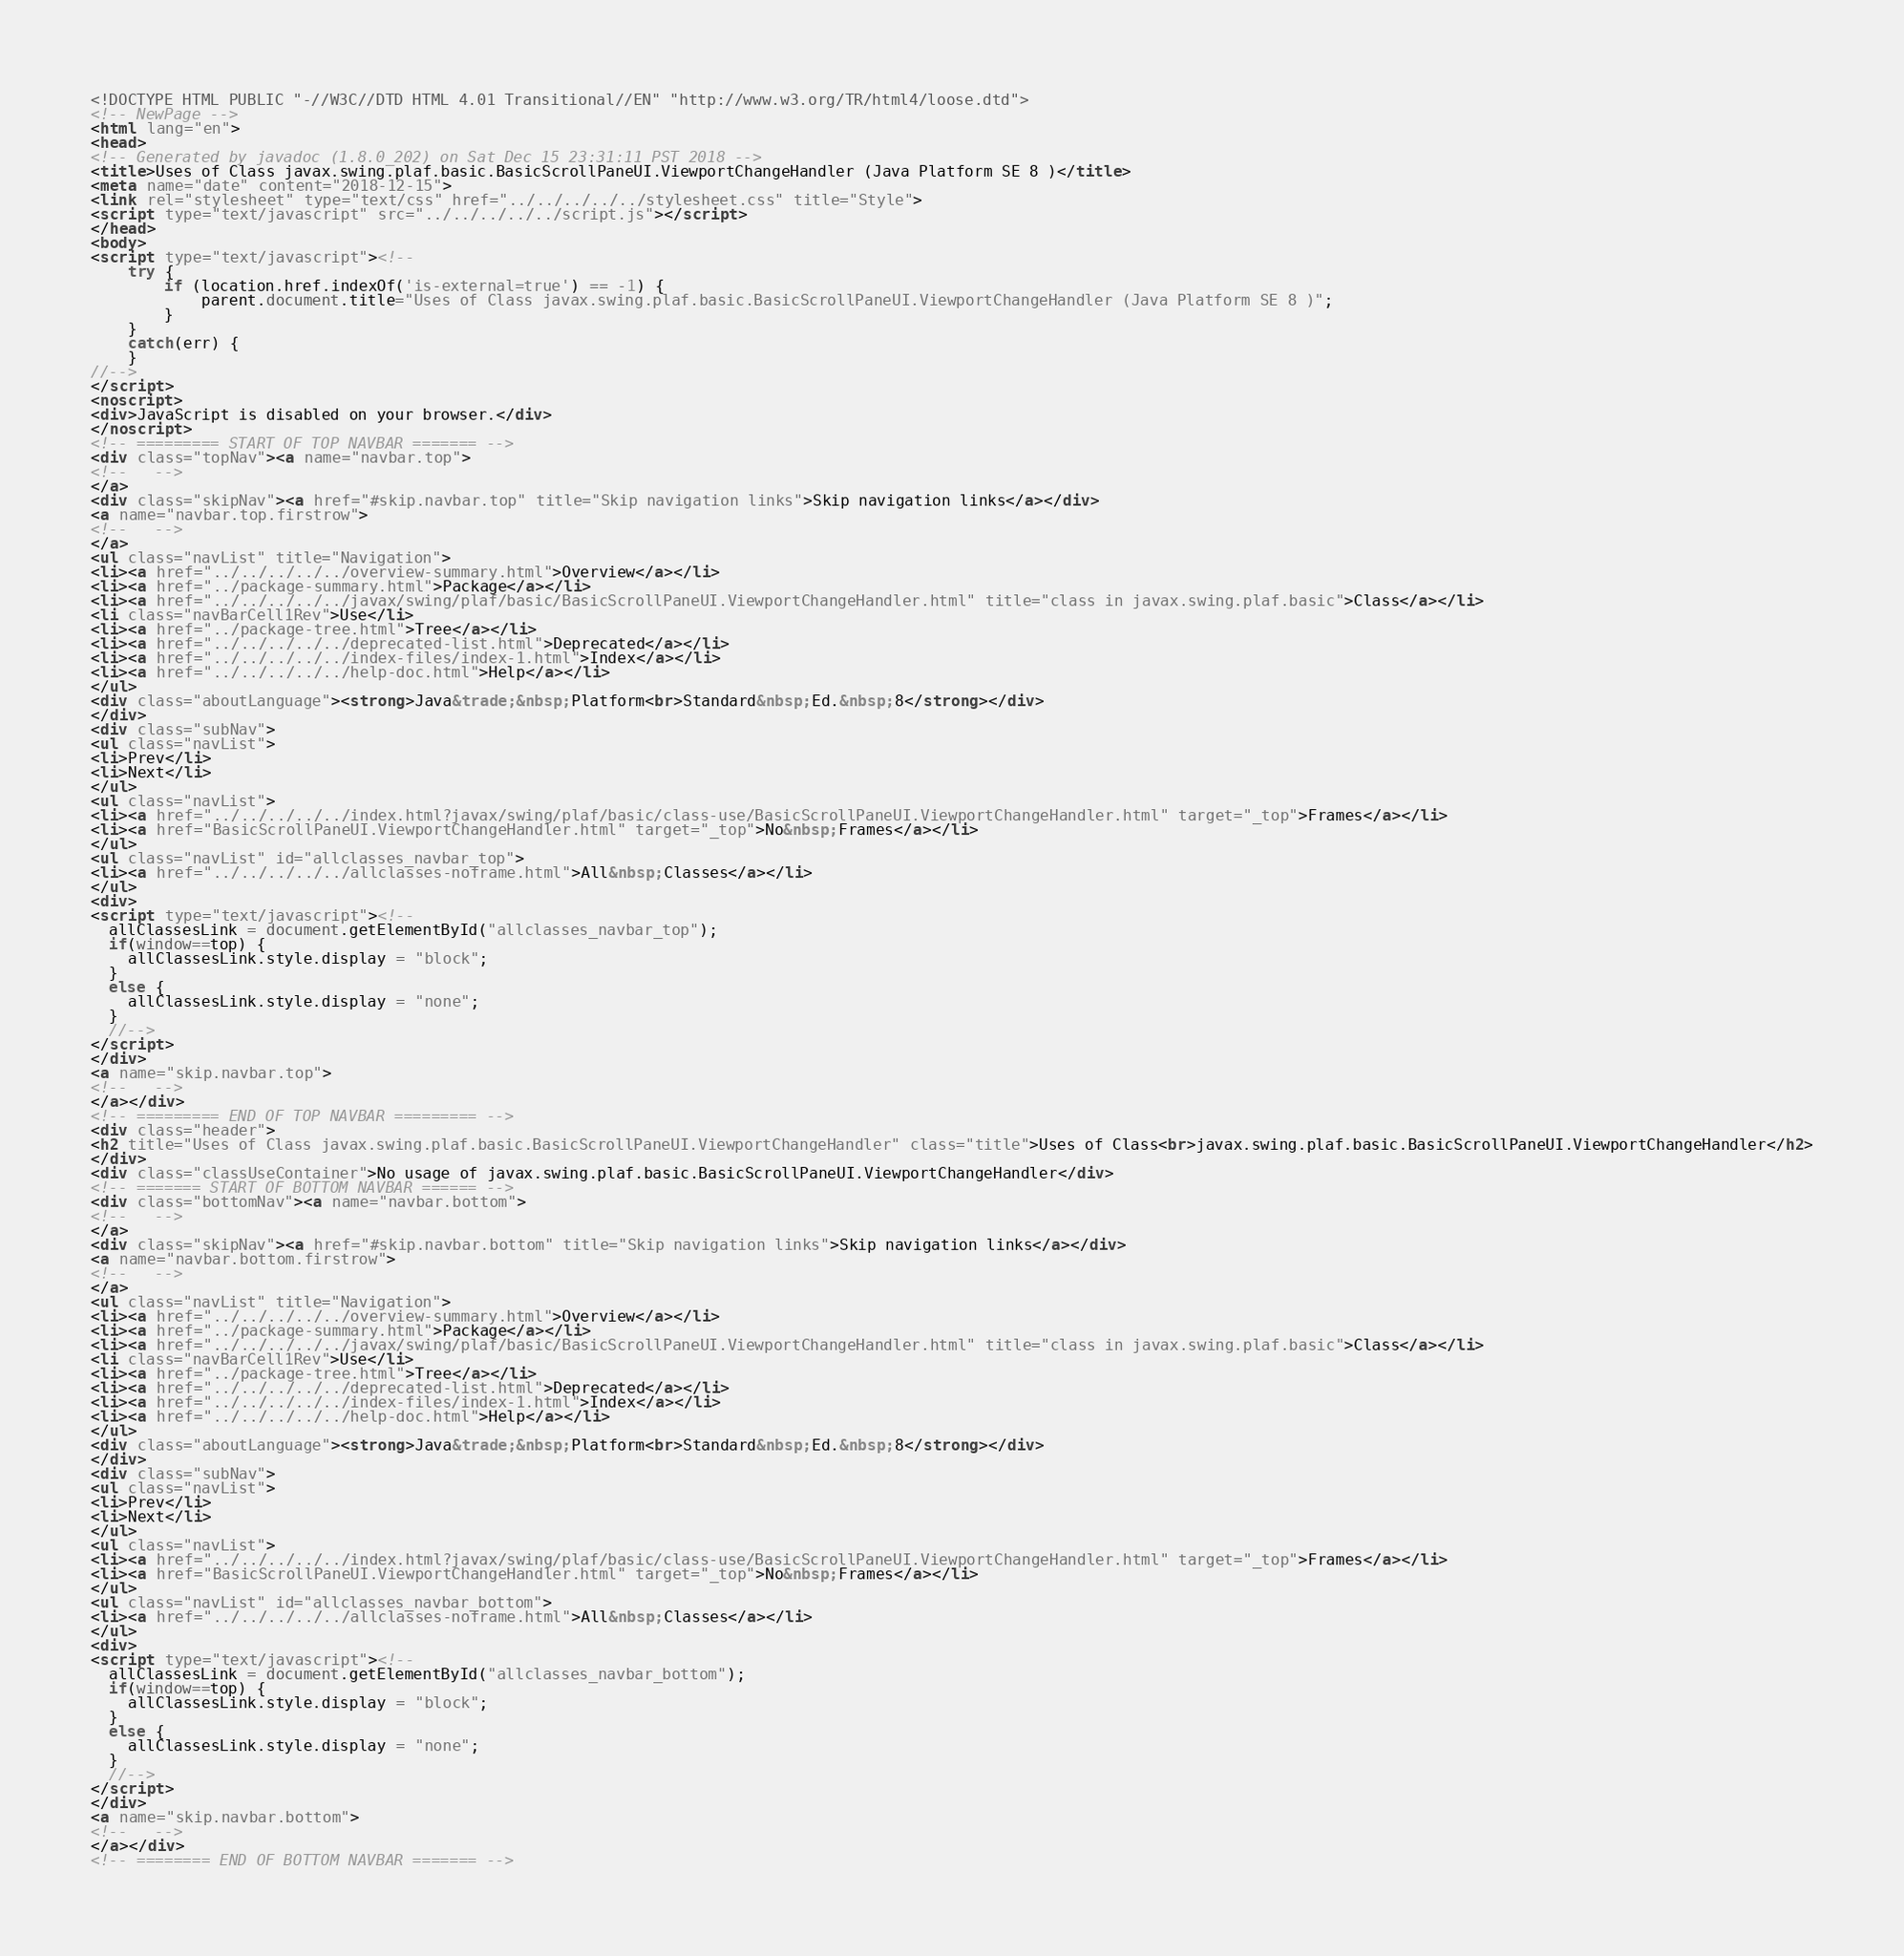Convert code to text. <code><loc_0><loc_0><loc_500><loc_500><_HTML_><!DOCTYPE HTML PUBLIC "-//W3C//DTD HTML 4.01 Transitional//EN" "http://www.w3.org/TR/html4/loose.dtd">
<!-- NewPage -->
<html lang="en">
<head>
<!-- Generated by javadoc (1.8.0_202) on Sat Dec 15 23:31:11 PST 2018 -->
<title>Uses of Class javax.swing.plaf.basic.BasicScrollPaneUI.ViewportChangeHandler (Java Platform SE 8 )</title>
<meta name="date" content="2018-12-15">
<link rel="stylesheet" type="text/css" href="../../../../../stylesheet.css" title="Style">
<script type="text/javascript" src="../../../../../script.js"></script>
</head>
<body>
<script type="text/javascript"><!--
    try {
        if (location.href.indexOf('is-external=true') == -1) {
            parent.document.title="Uses of Class javax.swing.plaf.basic.BasicScrollPaneUI.ViewportChangeHandler (Java Platform SE 8 )";
        }
    }
    catch(err) {
    }
//-->
</script>
<noscript>
<div>JavaScript is disabled on your browser.</div>
</noscript>
<!-- ========= START OF TOP NAVBAR ======= -->
<div class="topNav"><a name="navbar.top">
<!--   -->
</a>
<div class="skipNav"><a href="#skip.navbar.top" title="Skip navigation links">Skip navigation links</a></div>
<a name="navbar.top.firstrow">
<!--   -->
</a>
<ul class="navList" title="Navigation">
<li><a href="../../../../../overview-summary.html">Overview</a></li>
<li><a href="../package-summary.html">Package</a></li>
<li><a href="../../../../../javax/swing/plaf/basic/BasicScrollPaneUI.ViewportChangeHandler.html" title="class in javax.swing.plaf.basic">Class</a></li>
<li class="navBarCell1Rev">Use</li>
<li><a href="../package-tree.html">Tree</a></li>
<li><a href="../../../../../deprecated-list.html">Deprecated</a></li>
<li><a href="../../../../../index-files/index-1.html">Index</a></li>
<li><a href="../../../../../help-doc.html">Help</a></li>
</ul>
<div class="aboutLanguage"><strong>Java&trade;&nbsp;Platform<br>Standard&nbsp;Ed.&nbsp;8</strong></div>
</div>
<div class="subNav">
<ul class="navList">
<li>Prev</li>
<li>Next</li>
</ul>
<ul class="navList">
<li><a href="../../../../../index.html?javax/swing/plaf/basic/class-use/BasicScrollPaneUI.ViewportChangeHandler.html" target="_top">Frames</a></li>
<li><a href="BasicScrollPaneUI.ViewportChangeHandler.html" target="_top">No&nbsp;Frames</a></li>
</ul>
<ul class="navList" id="allclasses_navbar_top">
<li><a href="../../../../../allclasses-noframe.html">All&nbsp;Classes</a></li>
</ul>
<div>
<script type="text/javascript"><!--
  allClassesLink = document.getElementById("allclasses_navbar_top");
  if(window==top) {
    allClassesLink.style.display = "block";
  }
  else {
    allClassesLink.style.display = "none";
  }
  //-->
</script>
</div>
<a name="skip.navbar.top">
<!--   -->
</a></div>
<!-- ========= END OF TOP NAVBAR ========= -->
<div class="header">
<h2 title="Uses of Class javax.swing.plaf.basic.BasicScrollPaneUI.ViewportChangeHandler" class="title">Uses of Class<br>javax.swing.plaf.basic.BasicScrollPaneUI.ViewportChangeHandler</h2>
</div>
<div class="classUseContainer">No usage of javax.swing.plaf.basic.BasicScrollPaneUI.ViewportChangeHandler</div>
<!-- ======= START OF BOTTOM NAVBAR ====== -->
<div class="bottomNav"><a name="navbar.bottom">
<!--   -->
</a>
<div class="skipNav"><a href="#skip.navbar.bottom" title="Skip navigation links">Skip navigation links</a></div>
<a name="navbar.bottom.firstrow">
<!--   -->
</a>
<ul class="navList" title="Navigation">
<li><a href="../../../../../overview-summary.html">Overview</a></li>
<li><a href="../package-summary.html">Package</a></li>
<li><a href="../../../../../javax/swing/plaf/basic/BasicScrollPaneUI.ViewportChangeHandler.html" title="class in javax.swing.plaf.basic">Class</a></li>
<li class="navBarCell1Rev">Use</li>
<li><a href="../package-tree.html">Tree</a></li>
<li><a href="../../../../../deprecated-list.html">Deprecated</a></li>
<li><a href="../../../../../index-files/index-1.html">Index</a></li>
<li><a href="../../../../../help-doc.html">Help</a></li>
</ul>
<div class="aboutLanguage"><strong>Java&trade;&nbsp;Platform<br>Standard&nbsp;Ed.&nbsp;8</strong></div>
</div>
<div class="subNav">
<ul class="navList">
<li>Prev</li>
<li>Next</li>
</ul>
<ul class="navList">
<li><a href="../../../../../index.html?javax/swing/plaf/basic/class-use/BasicScrollPaneUI.ViewportChangeHandler.html" target="_top">Frames</a></li>
<li><a href="BasicScrollPaneUI.ViewportChangeHandler.html" target="_top">No&nbsp;Frames</a></li>
</ul>
<ul class="navList" id="allclasses_navbar_bottom">
<li><a href="../../../../../allclasses-noframe.html">All&nbsp;Classes</a></li>
</ul>
<div>
<script type="text/javascript"><!--
  allClassesLink = document.getElementById("allclasses_navbar_bottom");
  if(window==top) {
    allClassesLink.style.display = "block";
  }
  else {
    allClassesLink.style.display = "none";
  }
  //-->
</script>
</div>
<a name="skip.navbar.bottom">
<!--   -->
</a></div>
<!-- ======== END OF BOTTOM NAVBAR ======= --></code> 